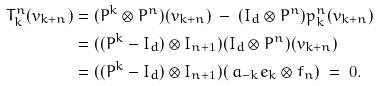<formula> <loc_0><loc_0><loc_500><loc_500>T ^ { n } _ { k } ( v _ { k + n } ) & = ( P ^ { k } \otimes P ^ { n } ) ( v _ { k + n } ) \ - \ ( I _ { d } \otimes P ^ { n } ) p ^ { n } _ { k } ( v _ { k + n } ) \\ & = ( ( P ^ { k } - I _ { d } ) \otimes I _ { n + 1 } ) ( I _ { d } \otimes P ^ { n } ) ( v _ { k + n } ) \\ & = ( ( P ^ { k } - I _ { d } ) \otimes I _ { n + 1 } ) ( \ a _ { - k } e _ { k } \otimes f _ { n } ) \ = \ 0 .</formula> 